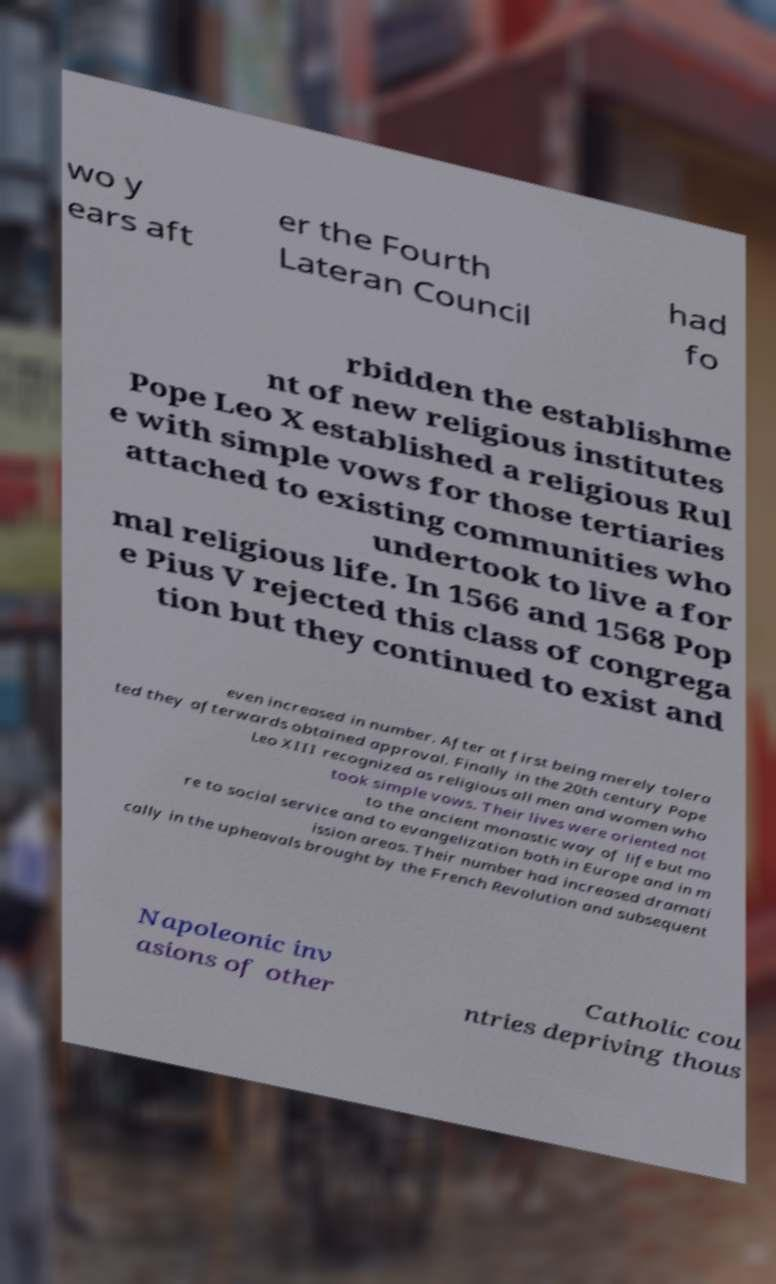Can you accurately transcribe the text from the provided image for me? wo y ears aft er the Fourth Lateran Council had fo rbidden the establishme nt of new religious institutes Pope Leo X established a religious Rul e with simple vows for those tertiaries attached to existing communities who undertook to live a for mal religious life. In 1566 and 1568 Pop e Pius V rejected this class of congrega tion but they continued to exist and even increased in number. After at first being merely tolera ted they afterwards obtained approval. Finally in the 20th century Pope Leo XIII recognized as religious all men and women who took simple vows. Their lives were oriented not to the ancient monastic way of life but mo re to social service and to evangelization both in Europe and in m ission areas. Their number had increased dramati cally in the upheavals brought by the French Revolution and subsequent Napoleonic inv asions of other Catholic cou ntries depriving thous 